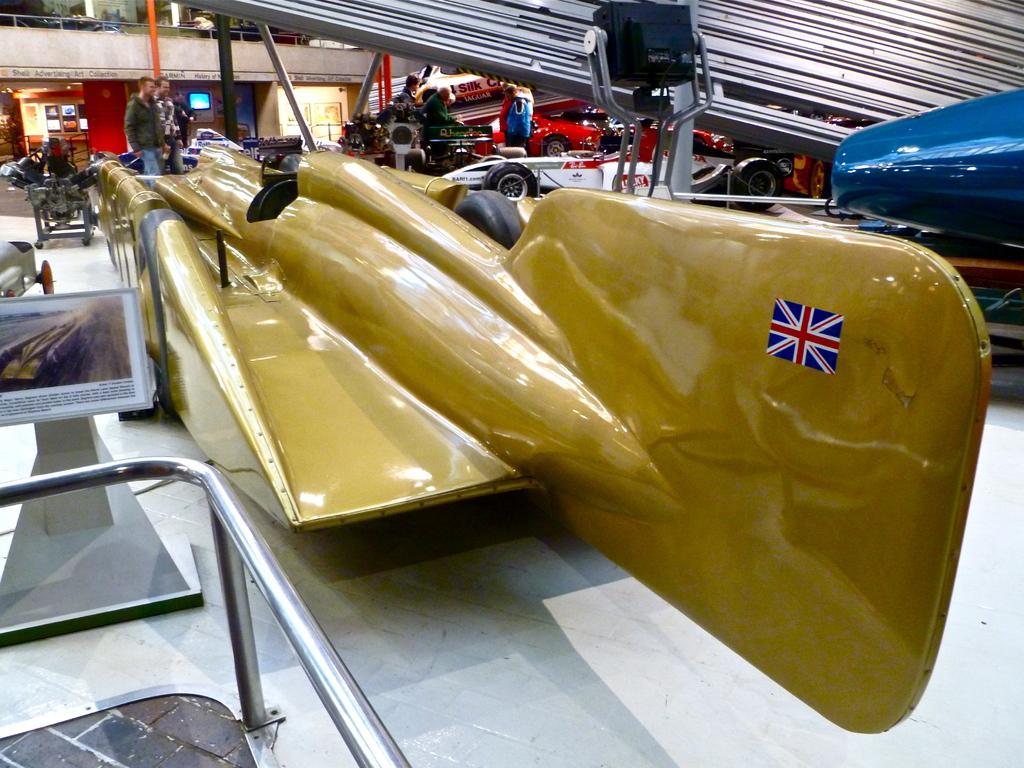In one or two sentences, can you explain what this image depicts? In this picture there are people and we can see vehicles, rods, board on stand, floor and metal object. In the background of the image we can see railing, wall, screen and objects. 